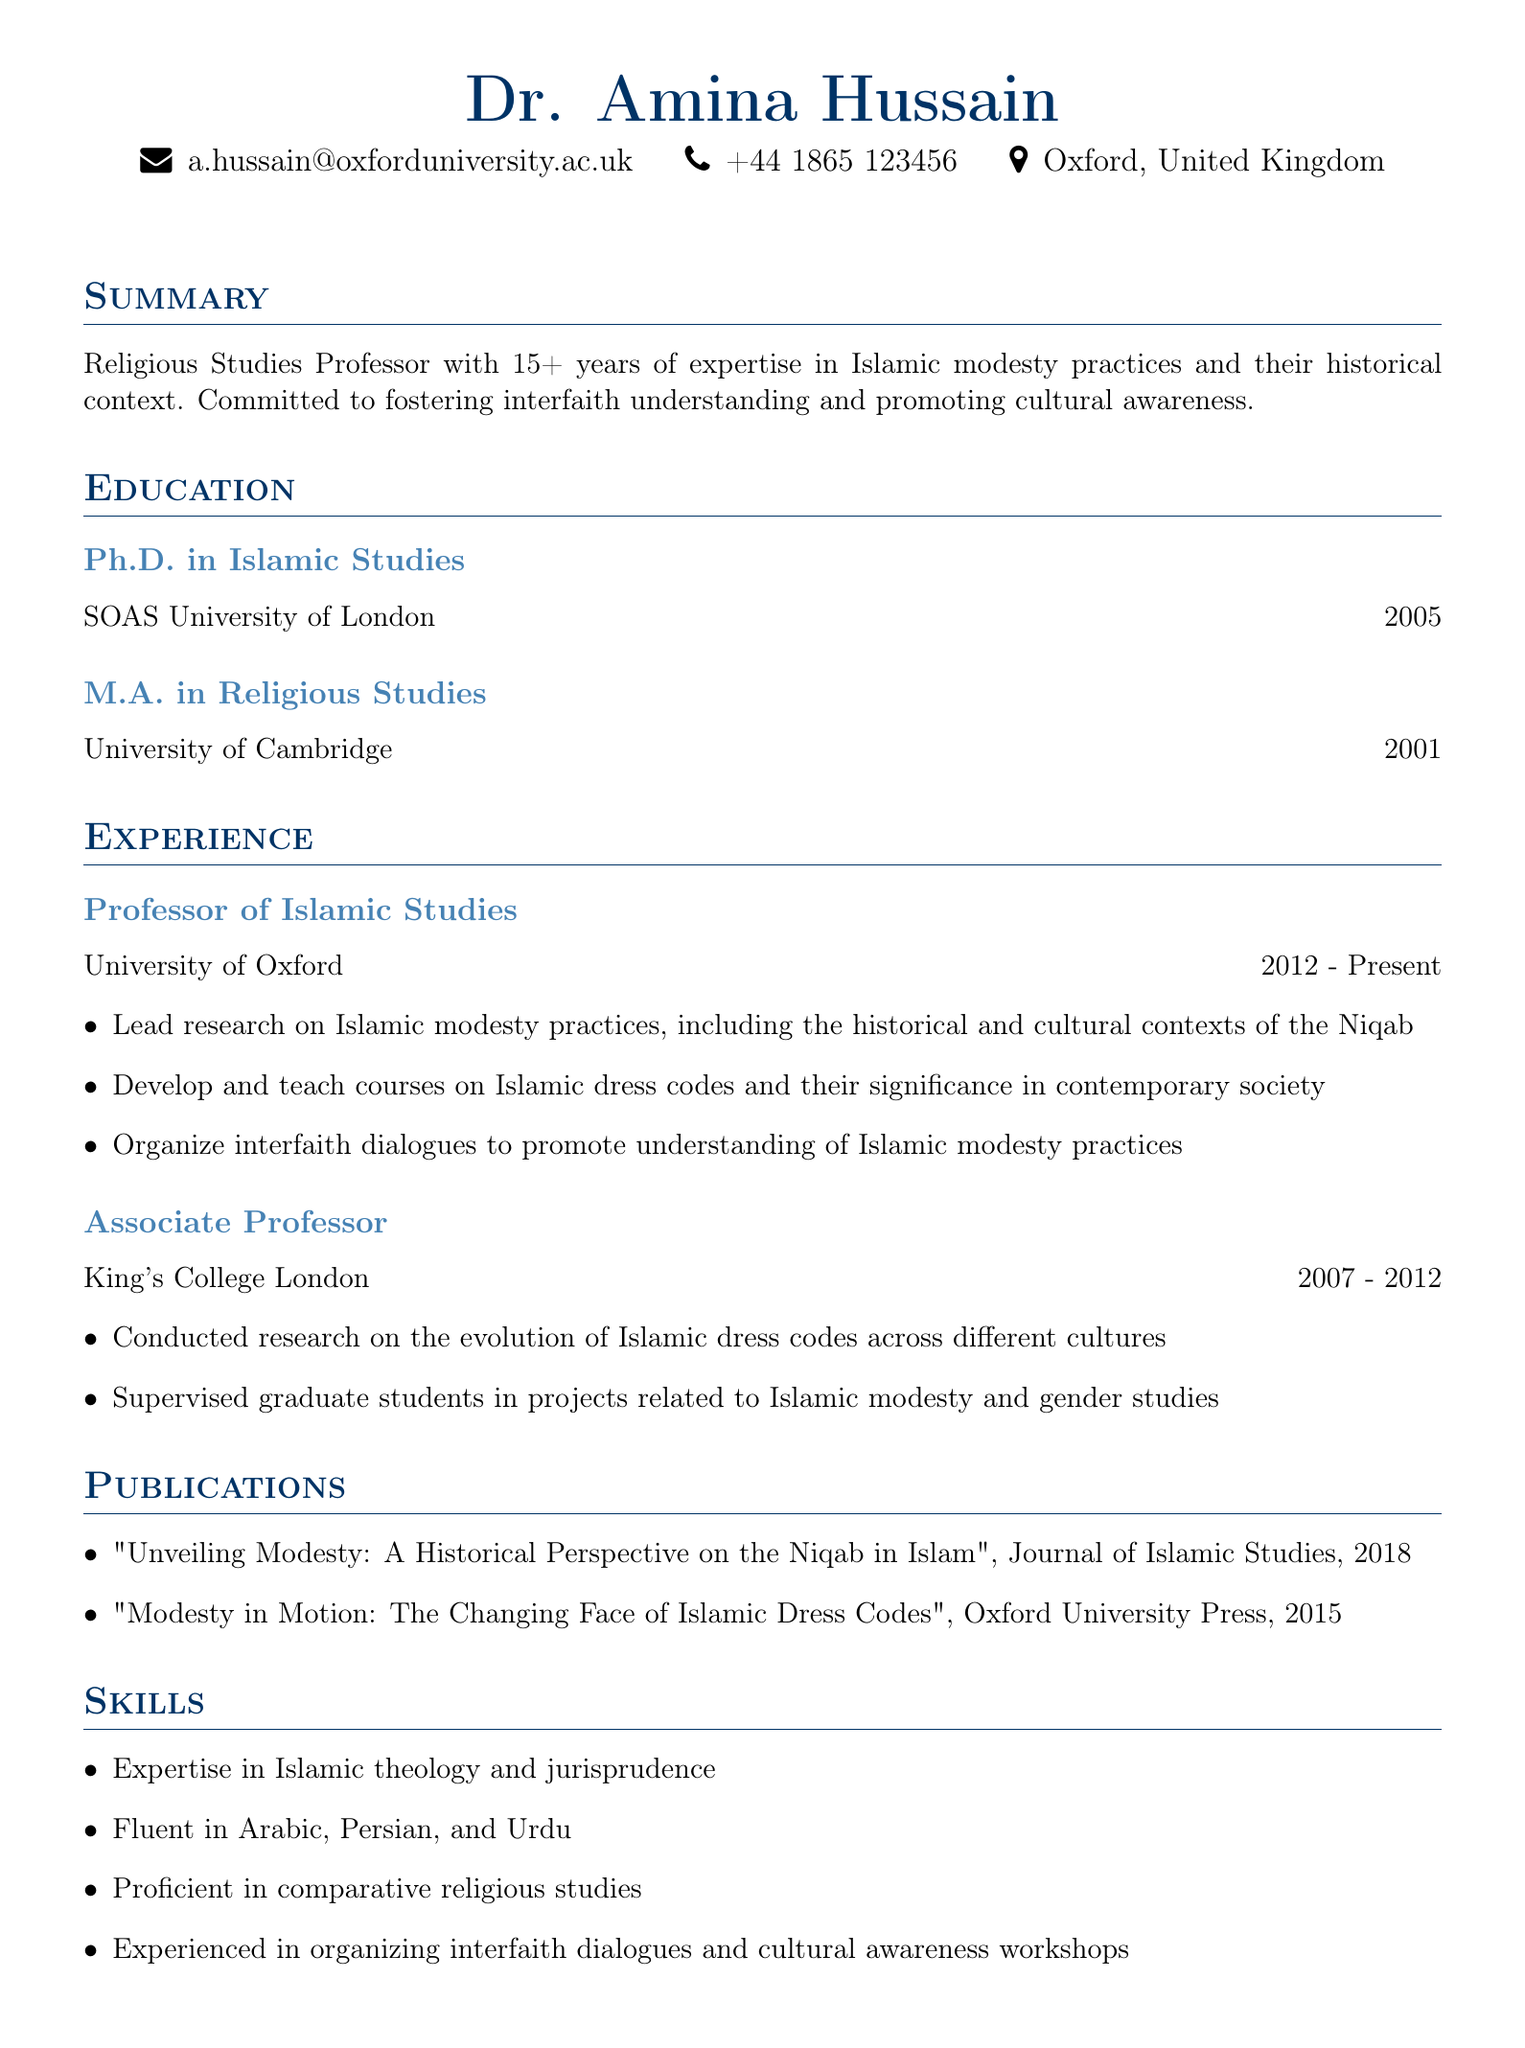What is the name of the professor? The professor's name is provided in the personal info section.
Answer: Dr. Amina Hussain What year did Dr. Hussain receive her Ph.D.? The document states the year in the education section.
Answer: 2005 Which university is Dr. Hussain currently employed at? The current employment is mentioned in the experience section of the document.
Answer: University of Oxford What publication did Dr. Hussain release in 2015? The publication year and title are listed in the publications section.
Answer: Modesty in Motion: The Changing Face of Islamic Dress Codes How many years of experience does Dr. Hussain have? The summary section includes the total years of experience.
Answer: 15+ What are Dr. Hussain's three areas of expertise? The skills section lists her expertise areas.
Answer: Islamic theology, jurisprudence, comparative religious studies At which institution was Dr. Hussain an associate professor? The experience section outlines her previous positions.
Answer: King's College London What is Dr. Hussain's email address? The email is displayed in the personal info section.
Answer: a.hussain@oxforduniversity.ac.uk What role does Dr. Hussain have in promoting cultural awareness? The summary section details her commitment to this role.
Answer: Foster interfaith understanding 